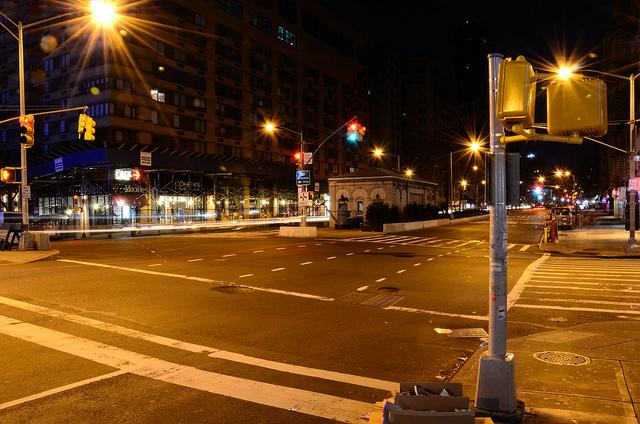How is the street staying illuminated?

Choices:
A) fire
B) sun
C) street lights
D) flashlights street lights 